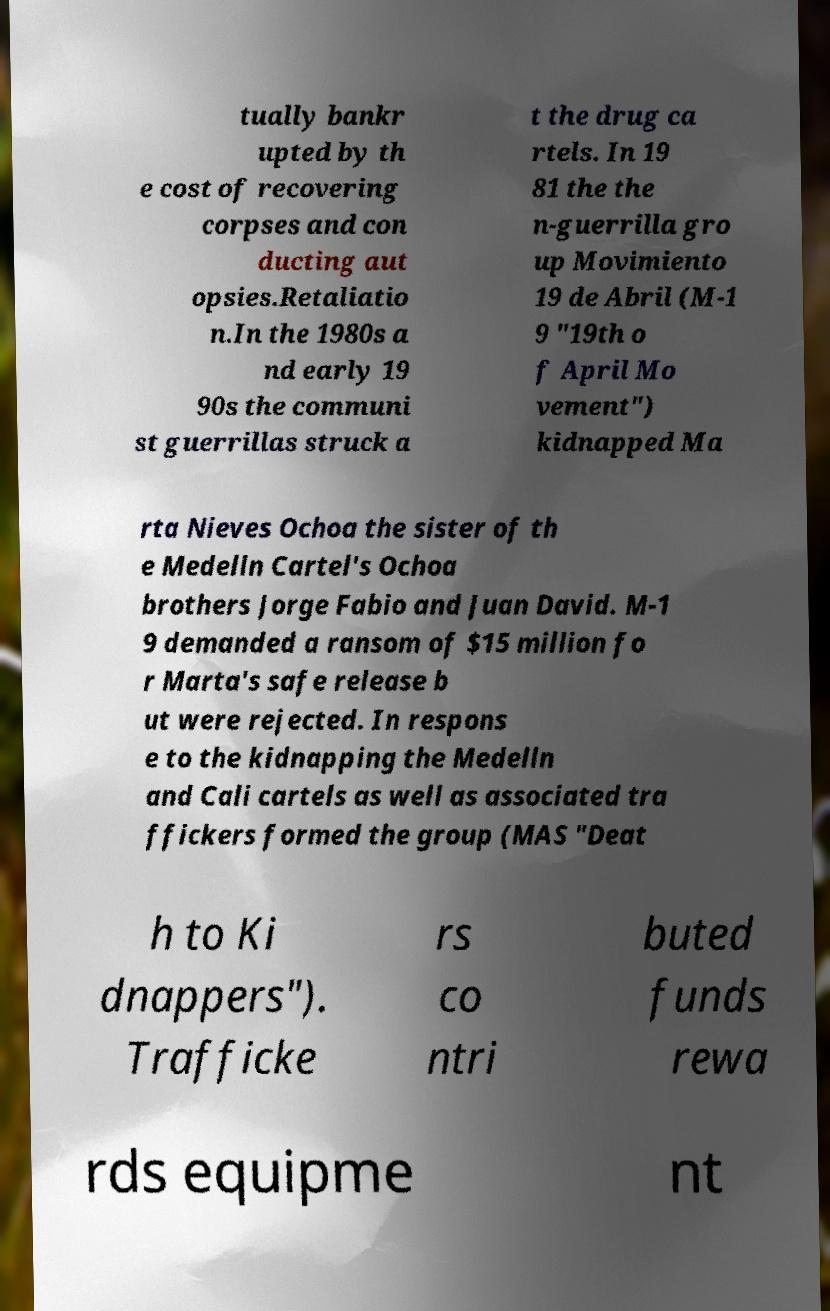Please identify and transcribe the text found in this image. tually bankr upted by th e cost of recovering corpses and con ducting aut opsies.Retaliatio n.In the 1980s a nd early 19 90s the communi st guerrillas struck a t the drug ca rtels. In 19 81 the the n-guerrilla gro up Movimiento 19 de Abril (M-1 9 "19th o f April Mo vement") kidnapped Ma rta Nieves Ochoa the sister of th e Medelln Cartel's Ochoa brothers Jorge Fabio and Juan David. M-1 9 demanded a ransom of $15 million fo r Marta's safe release b ut were rejected. In respons e to the kidnapping the Medelln and Cali cartels as well as associated tra ffickers formed the group (MAS "Deat h to Ki dnappers"). Trafficke rs co ntri buted funds rewa rds equipme nt 